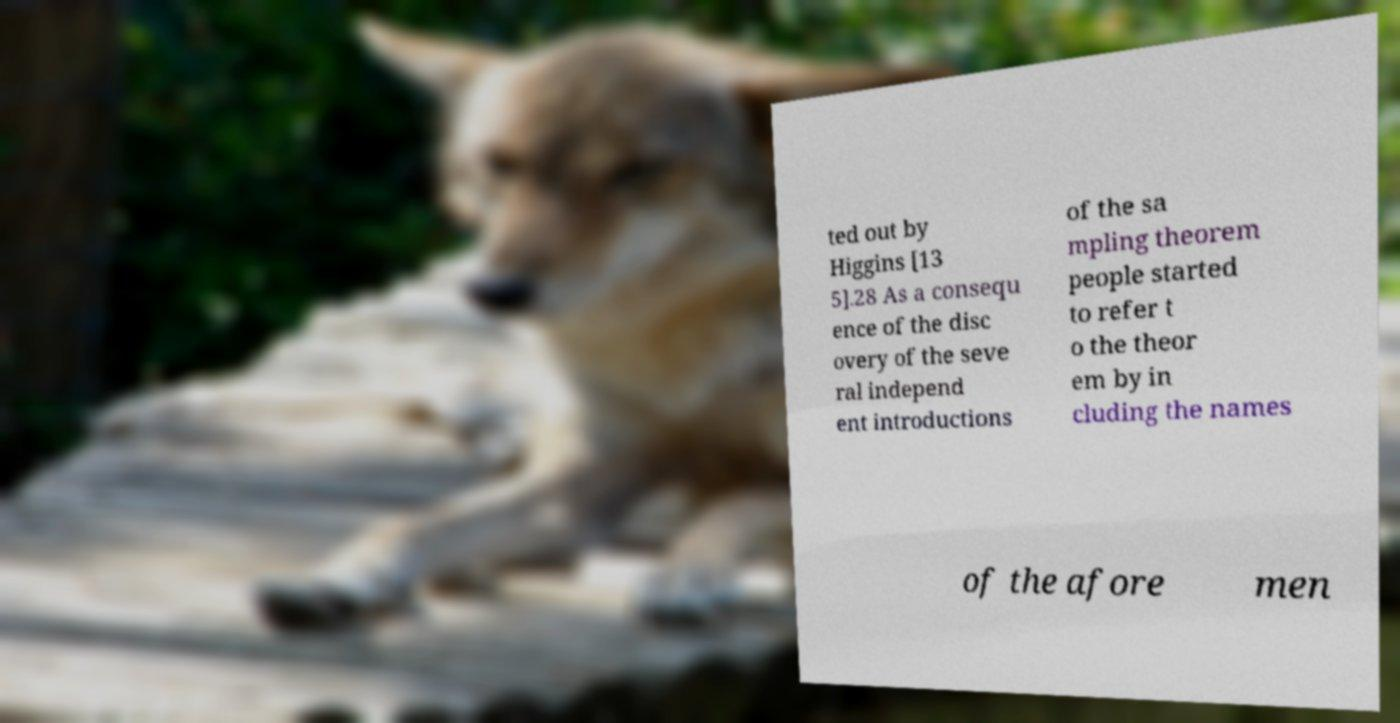Can you read and provide the text displayed in the image?This photo seems to have some interesting text. Can you extract and type it out for me? ted out by Higgins [13 5].28 As a consequ ence of the disc overy of the seve ral independ ent introductions of the sa mpling theorem people started to refer t o the theor em by in cluding the names of the afore men 